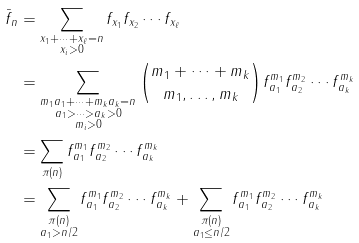Convert formula to latex. <formula><loc_0><loc_0><loc_500><loc_500>\bar { f } _ { n } & = \sum _ { \substack { x _ { 1 } + \cdots + x _ { \ell } = n \\ x _ { i } > 0 } } f _ { x _ { 1 } } f _ { x _ { 2 } } \cdots f _ { x _ { \ell } } \\ & = \sum _ { \substack { m _ { 1 } a _ { 1 } + \cdots + m _ { k } a _ { k } = n \\ a _ { 1 } > \cdots > a _ { k } > 0 \\ m _ { i } > 0 } } \binom { m _ { 1 } + \cdots + m _ { k } } { m _ { 1 } , \dots , m _ { k } } f _ { a _ { 1 } } ^ { m _ { 1 } } f _ { a _ { 2 } } ^ { m _ { 2 } } \cdots f _ { a _ { k } } ^ { m _ { k } } \\ & = \sum _ { \pi ( n ) } f _ { a _ { 1 } } ^ { m _ { 1 } } f _ { a _ { 2 } } ^ { m _ { 2 } } \cdots f _ { a _ { k } } ^ { m _ { k } } \\ & = \sum _ { \substack { \pi ( n ) \\ a _ { 1 } > n / 2 } } f _ { a _ { 1 } } ^ { m _ { 1 } } f _ { a _ { 2 } } ^ { m _ { 2 } } \cdots f _ { a _ { k } } ^ { m _ { k } } + \sum _ { \substack { \pi ( n ) \\ a _ { 1 } \leq n / 2 } } f _ { a _ { 1 } } ^ { m _ { 1 } } f _ { a _ { 2 } } ^ { m _ { 2 } } \cdots f _ { a _ { k } } ^ { m _ { k } }</formula> 